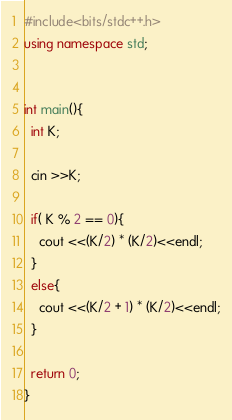<code> <loc_0><loc_0><loc_500><loc_500><_C++_>#include<bits/stdc++.h>
using namespace std;


int main(){
  int K;

  cin >>K;

  if( K % 2 == 0){
    cout <<(K/2) * (K/2)<<endl;
  }
  else{
    cout <<(K/2 + 1) * (K/2)<<endl;
  }

  return 0;
}
</code> 